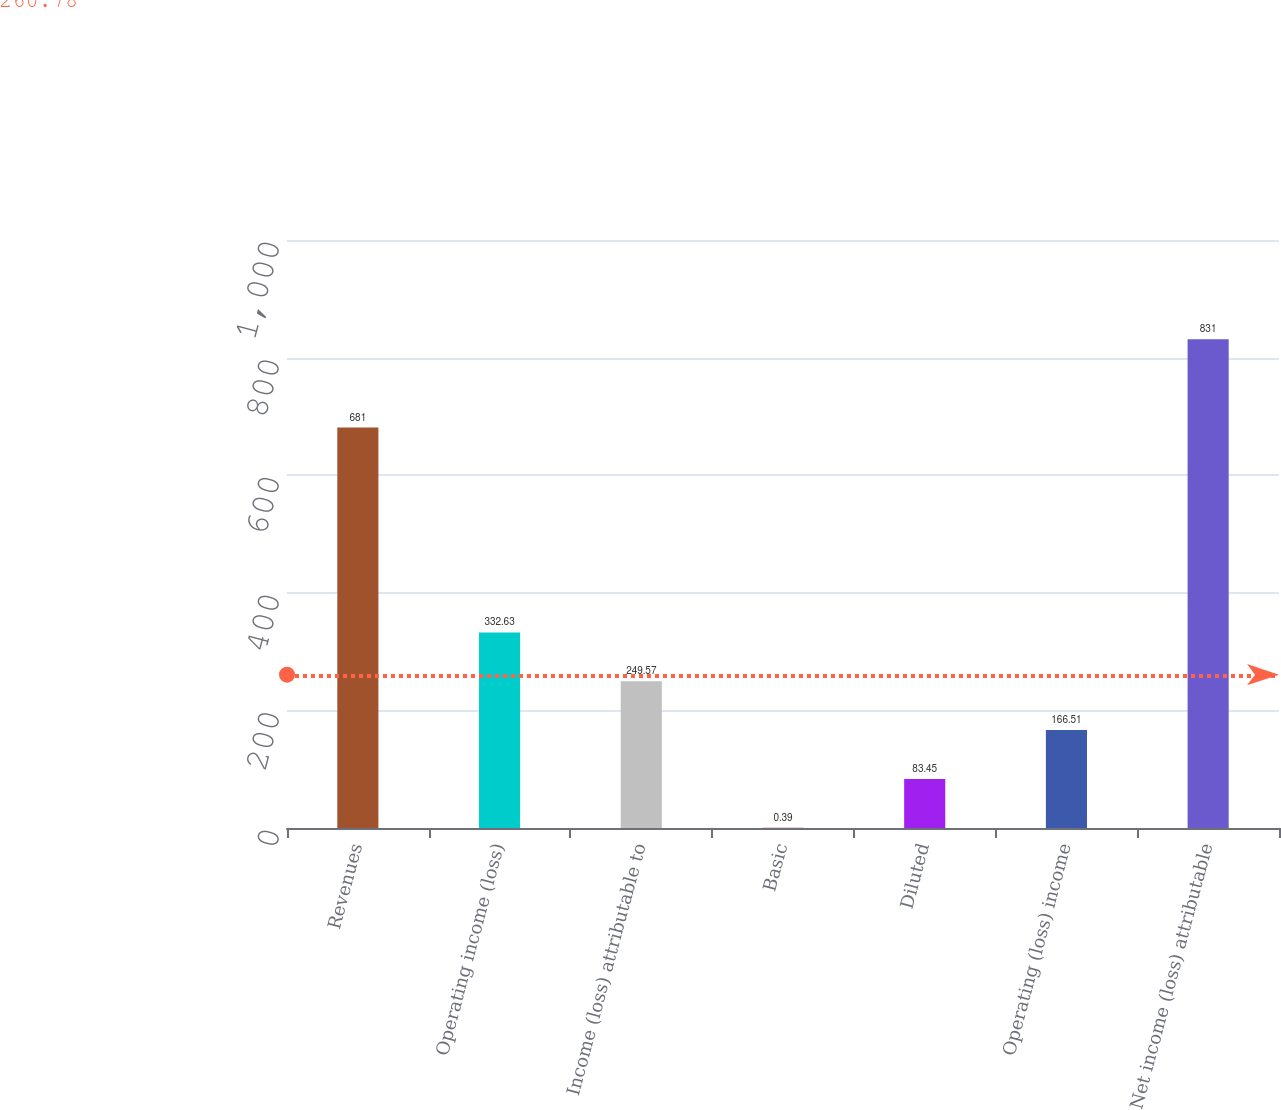Convert chart to OTSL. <chart><loc_0><loc_0><loc_500><loc_500><bar_chart><fcel>Revenues<fcel>Operating income (loss)<fcel>Income (loss) attributable to<fcel>Basic<fcel>Diluted<fcel>Operating (loss) income<fcel>Net income (loss) attributable<nl><fcel>681<fcel>332.63<fcel>249.57<fcel>0.39<fcel>83.45<fcel>166.51<fcel>831<nl></chart> 